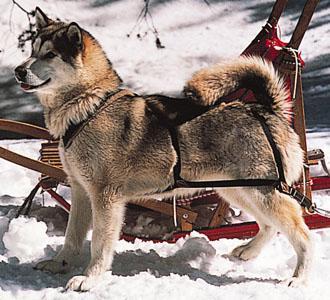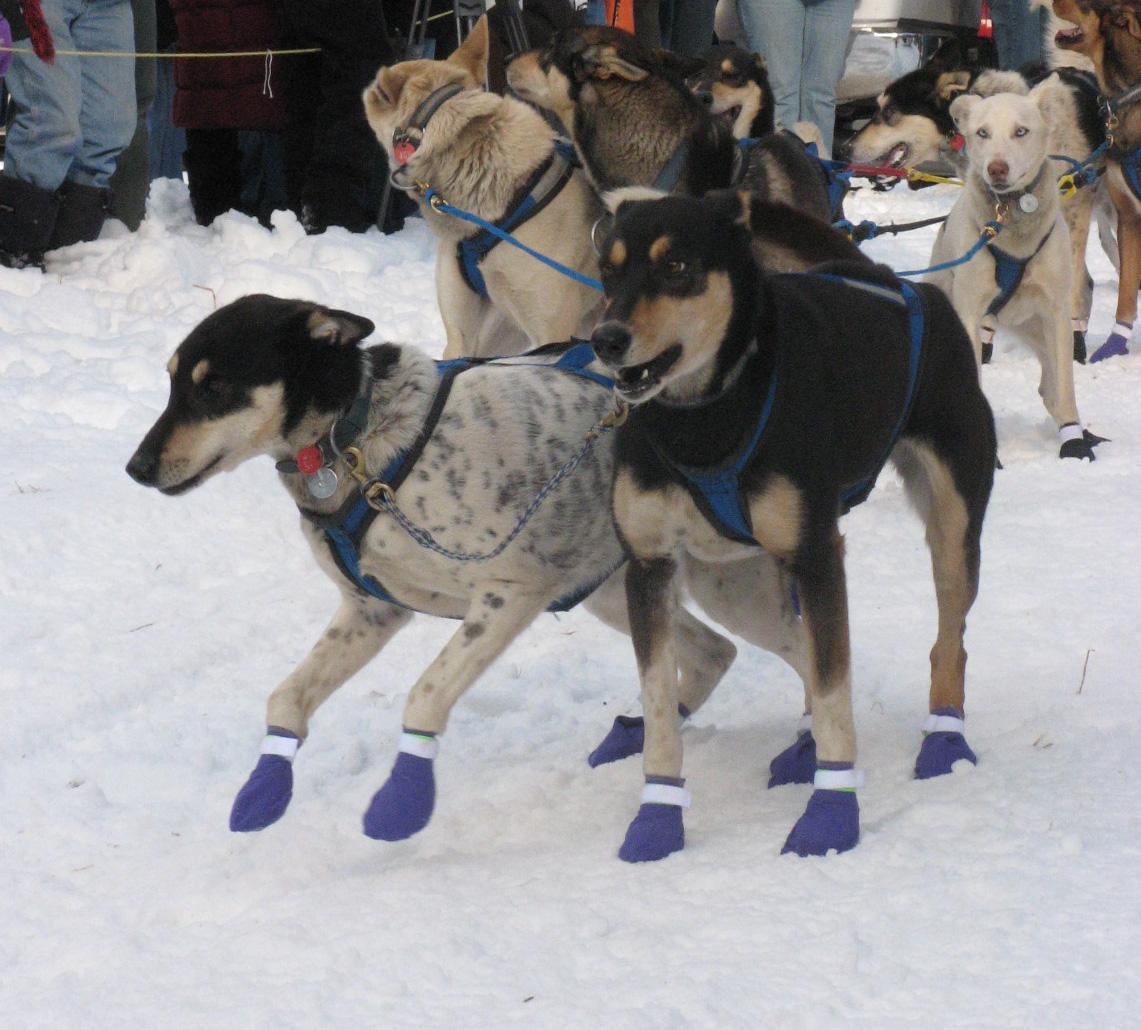The first image is the image on the left, the second image is the image on the right. Considering the images on both sides, is "There are only two dogs pulling one of the sleds." valid? Answer yes or no. No. The first image is the image on the left, the second image is the image on the right. For the images displayed, is the sentence "One dog team with a sled driver standing in back is headed forward and to the left down snowy ground with no bystanders." factually correct? Answer yes or no. No. 